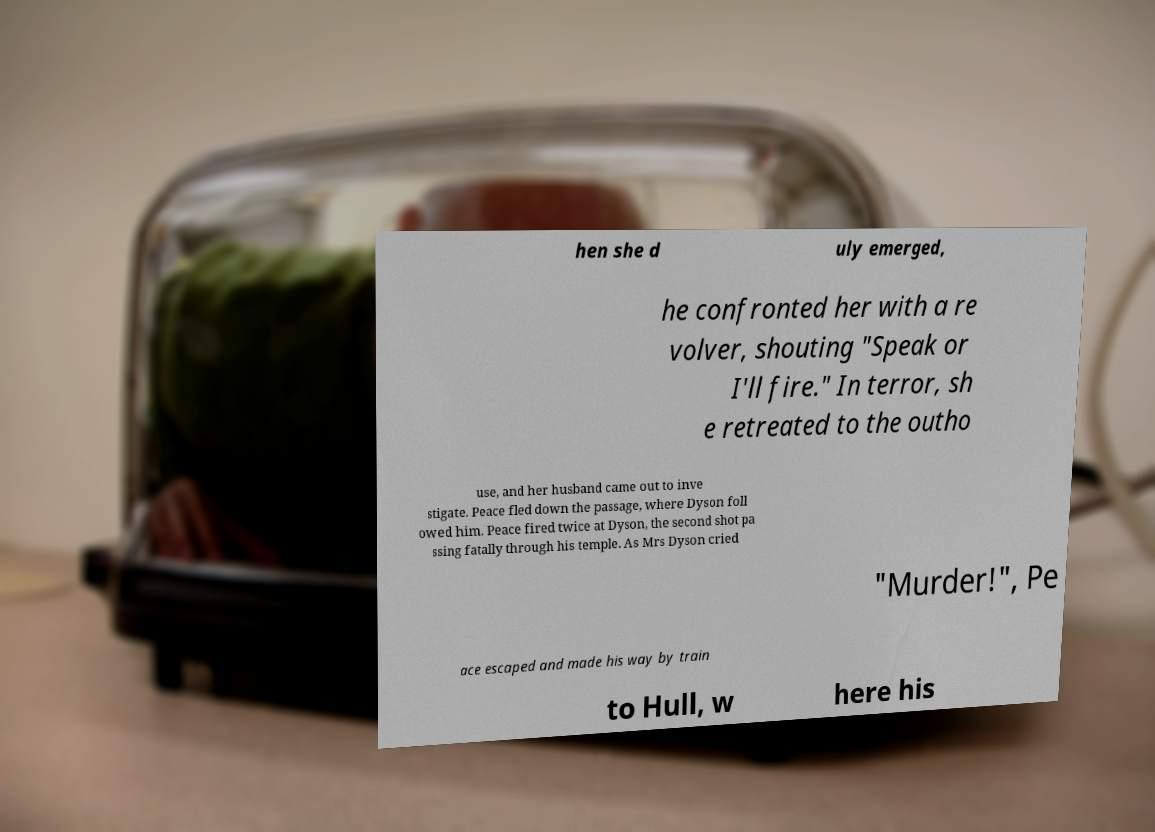Can you read and provide the text displayed in the image?This photo seems to have some interesting text. Can you extract and type it out for me? hen she d uly emerged, he confronted her with a re volver, shouting "Speak or I'll fire." In terror, sh e retreated to the outho use, and her husband came out to inve stigate. Peace fled down the passage, where Dyson foll owed him. Peace fired twice at Dyson, the second shot pa ssing fatally through his temple. As Mrs Dyson cried "Murder!", Pe ace escaped and made his way by train to Hull, w here his 